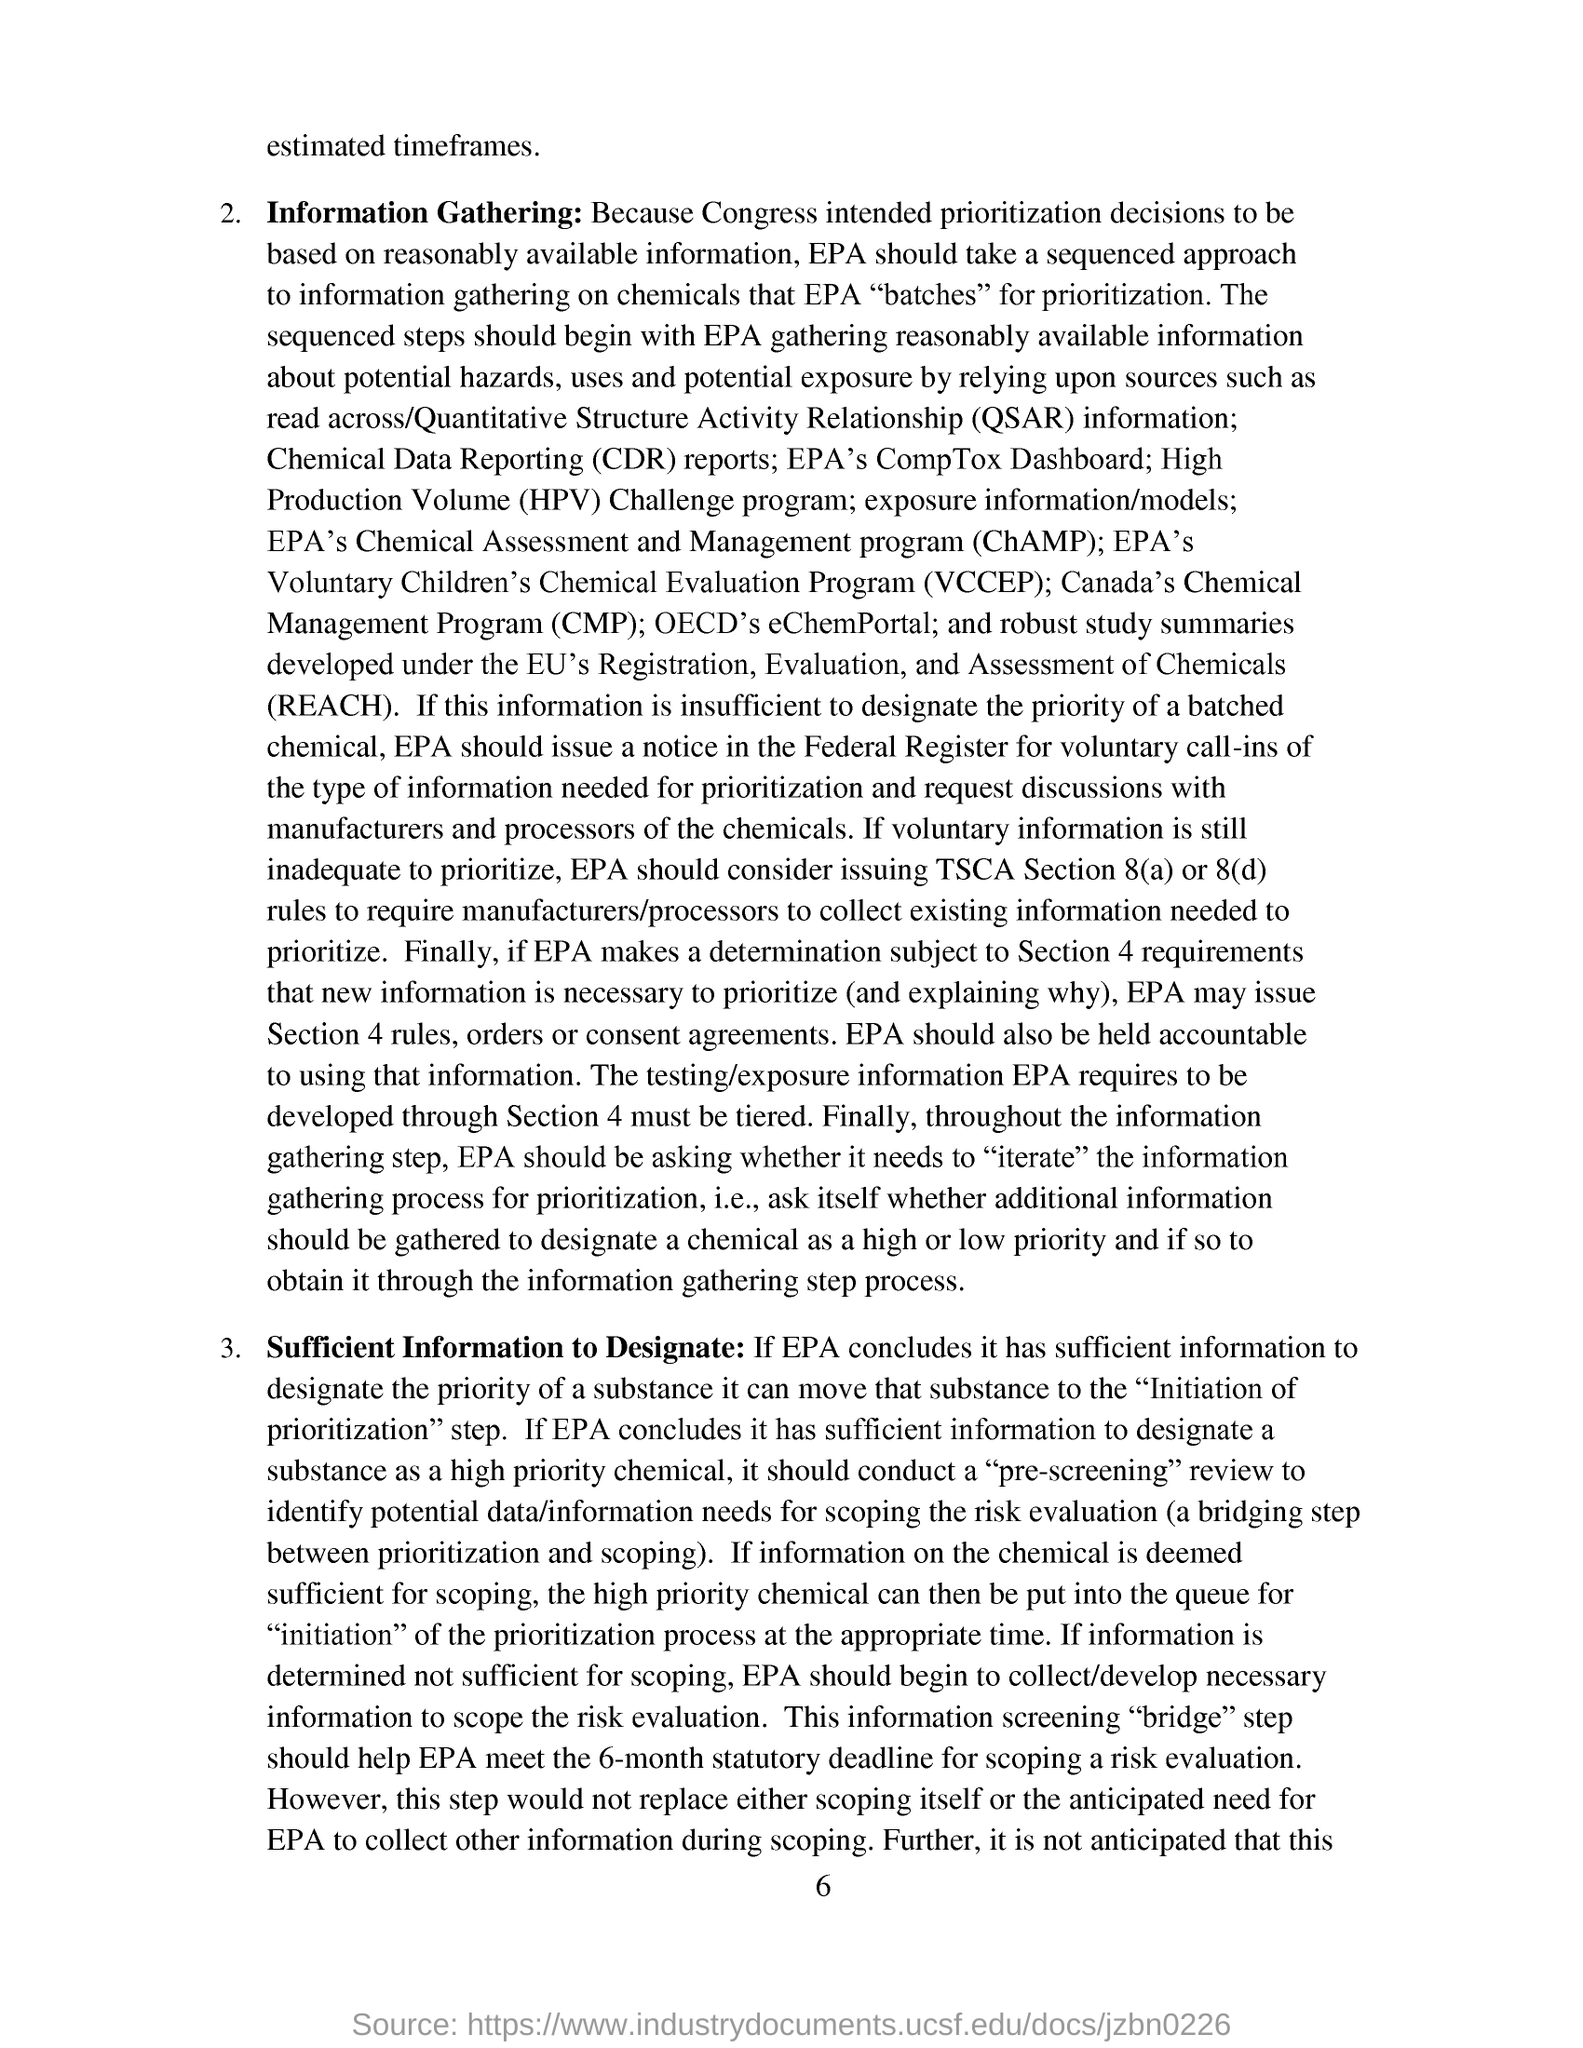What does QSAR stands for?
Make the answer very short. Quantitative structure activity relationship. 